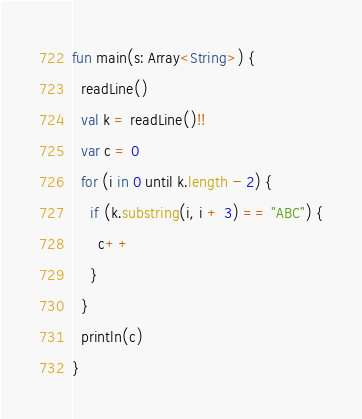Convert code to text. <code><loc_0><loc_0><loc_500><loc_500><_Kotlin_>fun main(s: Array<String>) {
  readLine()
  val k = readLine()!!
  var c = 0
  for (i in 0 until k.length - 2) {
    if (k.substring(i, i + 3) == "ABC") {
      c++
    }
  }
  println(c)
}</code> 